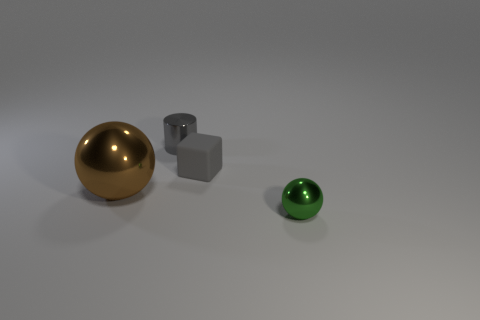Subtract all brown cylinders. How many brown balls are left? 1 Subtract all tiny gray objects. Subtract all cylinders. How many objects are left? 1 Add 2 brown metallic spheres. How many brown metallic spheres are left? 3 Add 1 small green things. How many small green things exist? 2 Add 3 tiny gray rubber things. How many objects exist? 7 Subtract all brown balls. How many balls are left? 1 Subtract 0 blue balls. How many objects are left? 4 Subtract all cubes. How many objects are left? 3 Subtract 1 blocks. How many blocks are left? 0 Subtract all purple cubes. Subtract all cyan spheres. How many cubes are left? 1 